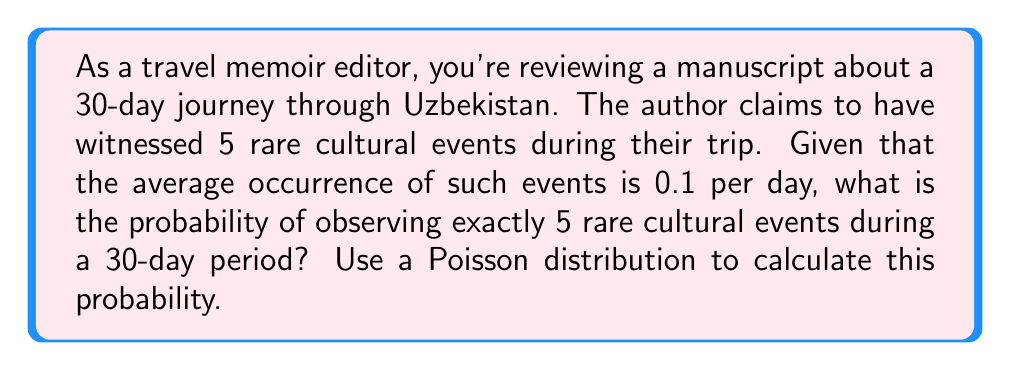Help me with this question. To solve this problem, we'll use the Poisson distribution, which is suitable for modeling the number of events occurring in a fixed interval of time or space.

The Poisson probability mass function is given by:

$$P(X = k) = \frac{e^{-\lambda} \lambda^k}{k!}$$

Where:
$\lambda$ = average number of events per interval
$k$ = number of events we're interested in
$e$ = Euler's number (approximately 2.71828)

Step 1: Calculate $\lambda$ for the 30-day period
$\lambda = 0.1 \text{ events/day} \times 30 \text{ days} = 3$

Step 2: Plug in the values to the Poisson formula
$k = 5$ (we want exactly 5 events)
$\lambda = 3$

$$P(X = 5) = \frac{e^{-3} 3^5}{5!}$$

Step 3: Calculate the result
$$P(X = 5) = \frac{e^{-3} \times 3^5}{5!} = \frac{e^{-3} \times 243}{120} \approx 0.1008$$

Step 4: Convert to percentage
$0.1008 \times 100\% = 10.08\%$
Answer: 10.08% 